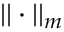<formula> <loc_0><loc_0><loc_500><loc_500>| | \cdot | | _ { m }</formula> 